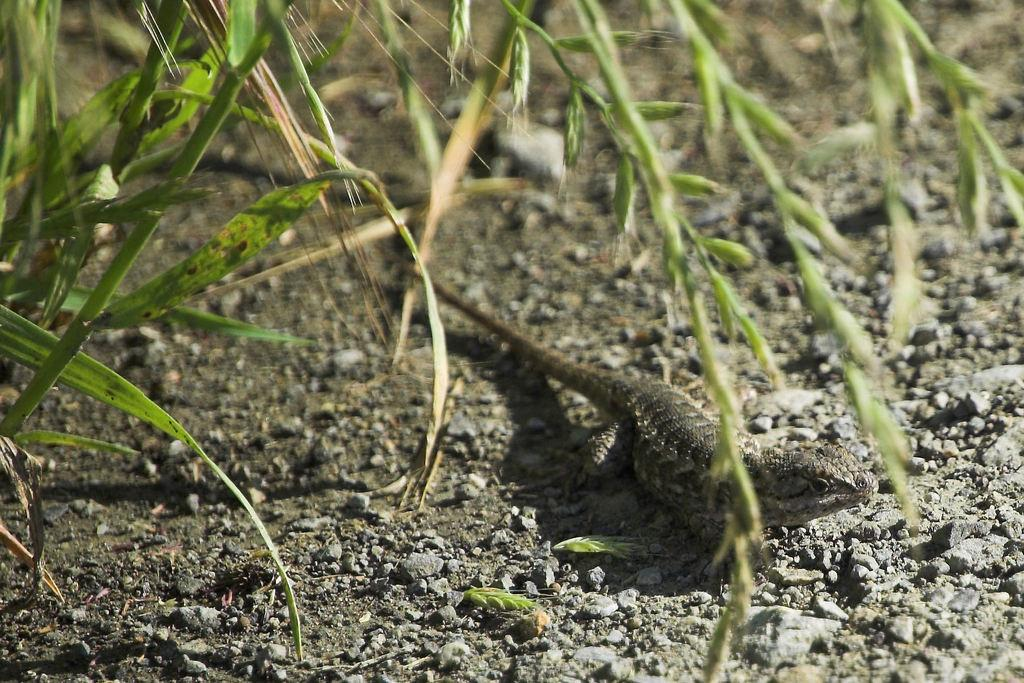What type of animal is in the image? There is a reptile in the image. What type of vegetation is present in the image? There is grass in the image. What type of objects are at the bottom of the image? There are stones at the bottom of the image. What type of string is being played by the crowd in the image? There is no crowd or string present in the image. 